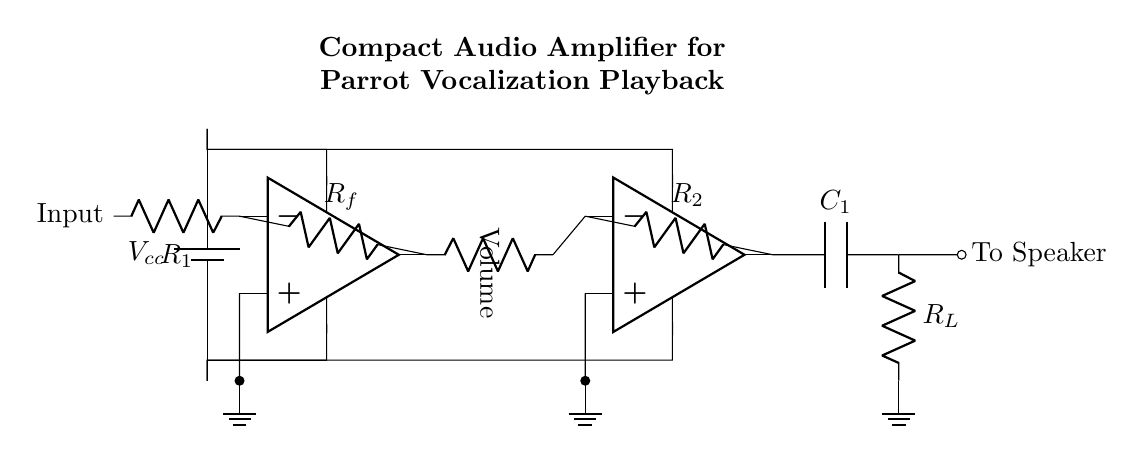What is the power supply voltage? The diagram indicates the power supply connected at the top labeled as Vcc. It does not specify a numerical value, so it generally refers to the positive voltage supplied to the circuit.
Answer: Vcc What are the resistor values in the circuit? The diagram shows resistors labeled as R1, Rf, and R2; however, it does not provide specific numerical values for these resistors. Thus, their values remain unspecified.
Answer: Unsigned values What is the function of the capacitors in the output stage? The capacitor labeled C1 is used for filtering in the output stage. It is connected in series with the load resistor RL, which allows AC signals to pass while blocking DC components.
Answer: Filtering How many operational amplifiers are present in the circuit? The circuit features two operational amplifiers connected in sequence for amplification purposes. Each op-amp serves a stage in the overall amplification process.
Answer: Two What is the purpose of the volume control component? The volume control is present as a potentiometer in the circuit that adjusts the amplitude of the audio signal before it is sent to the second amplifier stage. Its variable resistance allows for varying output levels.
Answer: Adjusts audio level What connects the first op-amp output to the second op-amp input? The output of the first op-amp is directly connected to the input of the second op-amp; specifically, this connection is labeled with "Volume," indicating that it is the signal processed with adjustable amplitude.
Answer: Volume control What type of load is represented by R_L in the circuit? The load resistor R_L typically represents the speaker impedance in audio applications. It connects to the output stage of the amplifier circuit, allowing the amplified audio signal to drive the speaker.
Answer: Speaker 